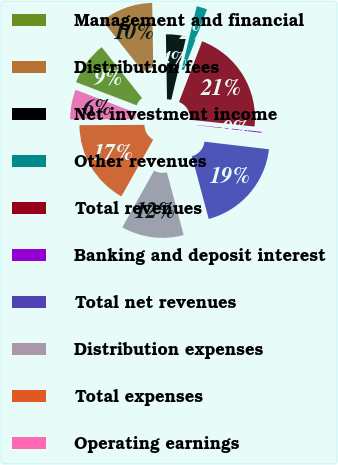Convert chart to OTSL. <chart><loc_0><loc_0><loc_500><loc_500><pie_chart><fcel>Management and financial<fcel>Distribution fees<fcel>Net investment income<fcel>Other revenues<fcel>Total revenues<fcel>Banking and deposit interest<fcel>Total net revenues<fcel>Distribution expenses<fcel>Total expenses<fcel>Operating earnings<nl><fcel>8.51%<fcel>10.4%<fcel>3.99%<fcel>2.09%<fcel>20.86%<fcel>0.2%<fcel>18.97%<fcel>12.3%<fcel>16.8%<fcel>5.89%<nl></chart> 